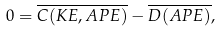<formula> <loc_0><loc_0><loc_500><loc_500>0 = \overline { C ( K E , A P E ) } - \overline { D ( A P E ) } ,</formula> 